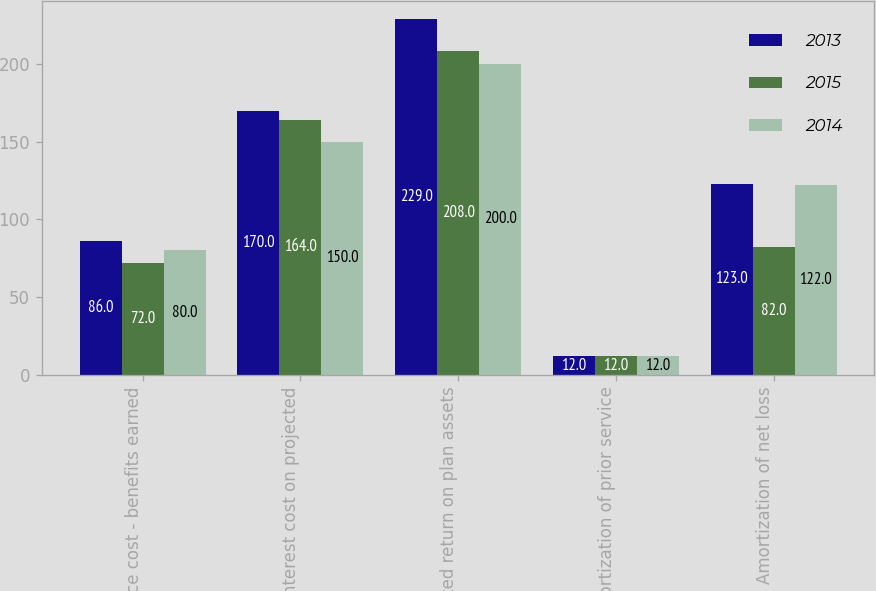Convert chart to OTSL. <chart><loc_0><loc_0><loc_500><loc_500><stacked_bar_chart><ecel><fcel>Service cost - benefits earned<fcel>Interest cost on projected<fcel>Expected return on plan assets<fcel>Amortization of prior service<fcel>Amortization of net loss<nl><fcel>2013<fcel>86<fcel>170<fcel>229<fcel>12<fcel>123<nl><fcel>2015<fcel>72<fcel>164<fcel>208<fcel>12<fcel>82<nl><fcel>2014<fcel>80<fcel>150<fcel>200<fcel>12<fcel>122<nl></chart> 